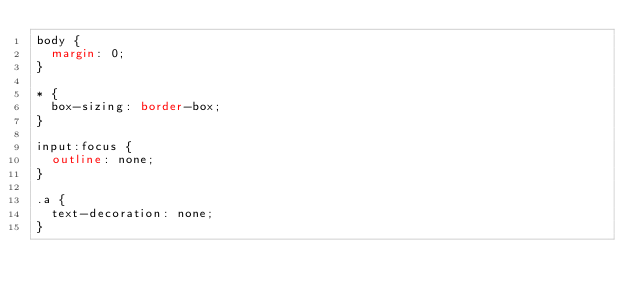<code> <loc_0><loc_0><loc_500><loc_500><_CSS_>body {
	margin: 0;
}

* {
	box-sizing: border-box;
}

input:focus {
	outline: none;
}

.a {
	text-decoration: none;
}</code> 